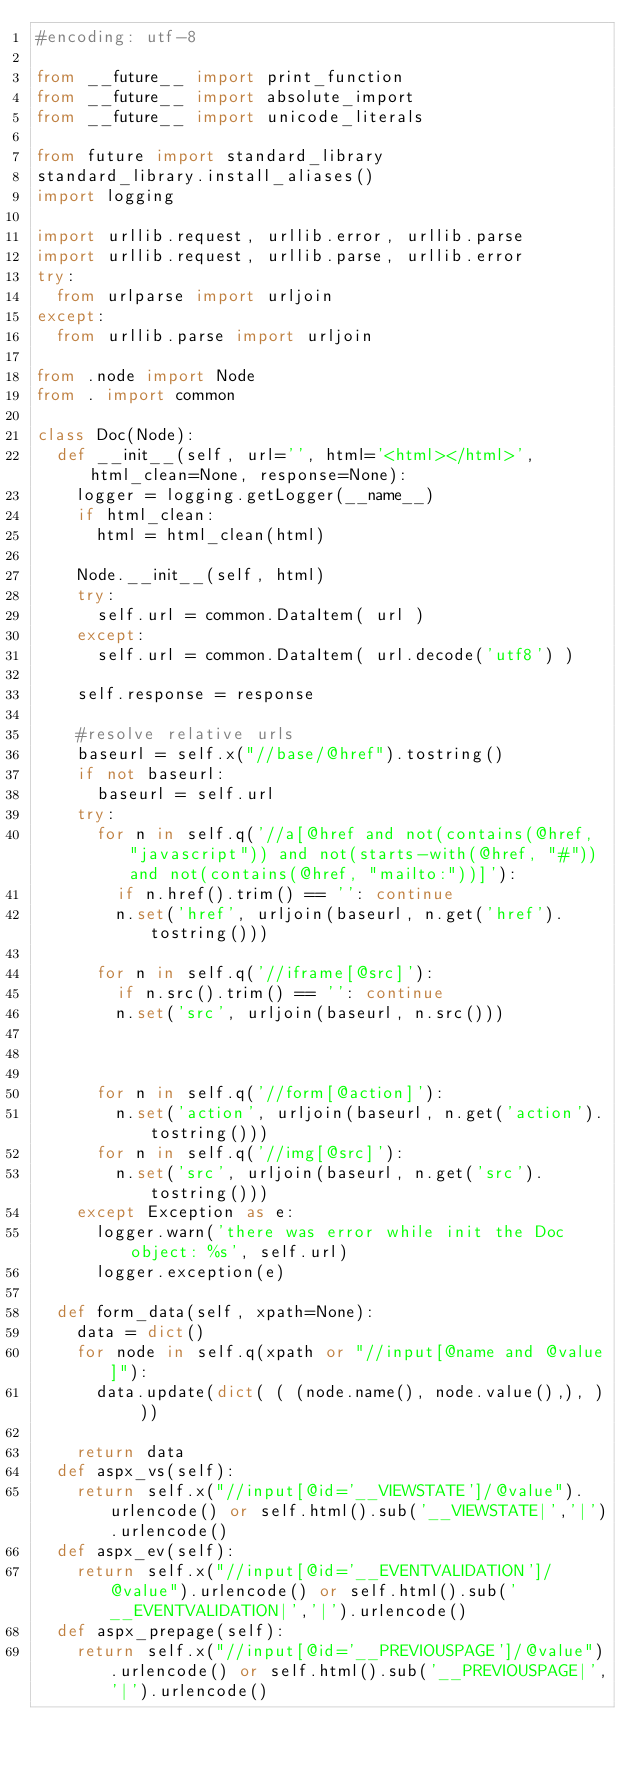Convert code to text. <code><loc_0><loc_0><loc_500><loc_500><_Python_>#encoding: utf-8

from __future__ import print_function
from __future__ import absolute_import
from __future__ import unicode_literals

from future import standard_library
standard_library.install_aliases()
import logging

import urllib.request, urllib.error, urllib.parse
import urllib.request, urllib.parse, urllib.error
try:
	from urlparse import urljoin
except:
	from urllib.parse import urljoin	

from .node import Node
from . import common

class Doc(Node):
	def __init__(self, url='', html='<html></html>', html_clean=None, response=None):
		logger = logging.getLogger(__name__)      
		if html_clean:
			html = html_clean(html)

		Node.__init__(self, html)
		try:
			self.url = common.DataItem( url )
		except:
			self.url = common.DataItem( url.decode('utf8') )	

		self.response = response
		
		#resolve relative urls
		baseurl = self.x("//base/@href").tostring()
		if not baseurl:
			baseurl = self.url
		try:
			for n in self.q('//a[@href and not(contains(@href, "javascript")) and not(starts-with(@href, "#")) and not(contains(@href, "mailto:"))]'):                  
				if n.href().trim() == '': continue
				n.set('href', urljoin(baseurl, n.get('href').tostring()))

			for n in self.q('//iframe[@src]'):                  
				if n.src().trim() == '': continue
				n.set('src', urljoin(baseurl, n.src()))
		


			for n in self.q('//form[@action]'):                 
				n.set('action', urljoin(baseurl, n.get('action').tostring()))  
			for n in self.q('//img[@src]'):                 
				n.set('src', urljoin(baseurl, n.get('src').tostring()))
		except Exception as e:
			logger.warn('there was error while init the Doc object: %s', self.url)
			logger.exception(e)
							
	def form_data(self, xpath=None):
		data = dict()
		for node in self.q(xpath or "//input[@name and @value]"):
			data.update(dict( ( (node.name(), node.value(),), ) ))

		return data 
	def aspx_vs(self):
		return self.x("//input[@id='__VIEWSTATE']/@value").urlencode() or self.html().sub('__VIEWSTATE|','|').urlencode()
	def aspx_ev(self):
		return self.x("//input[@id='__EVENTVALIDATION']/@value").urlencode() or self.html().sub('__EVENTVALIDATION|','|').urlencode()
	def aspx_prepage(self):
		return self.x("//input[@id='__PREVIOUSPAGE']/@value").urlencode() or self.html().sub('__PREVIOUSPAGE|','|').urlencode() 
</code> 